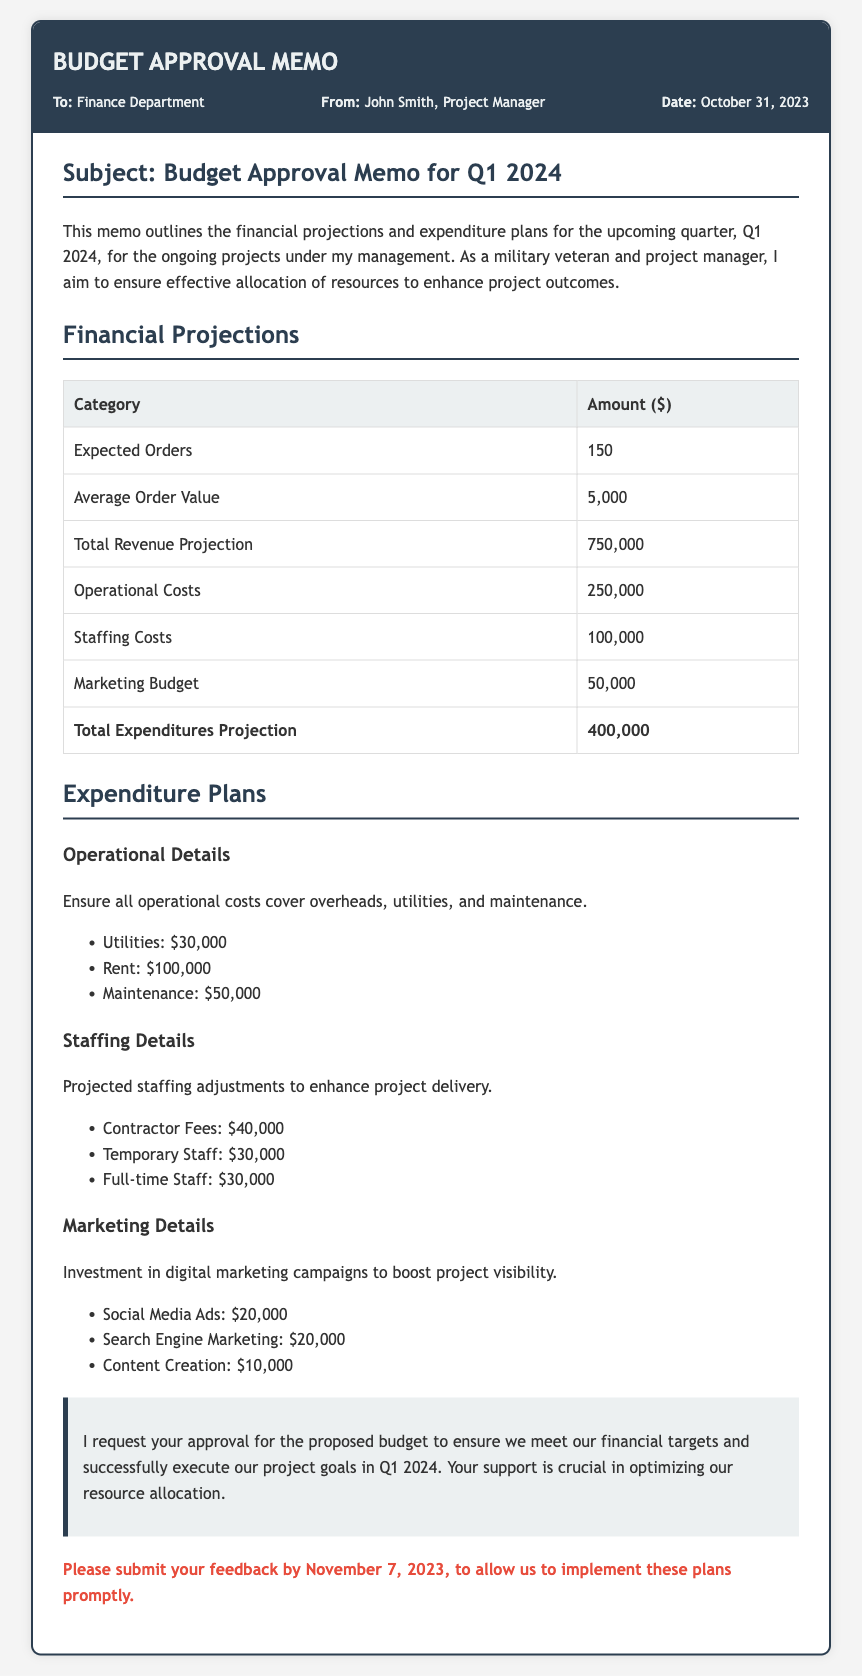what is the total revenue projection? The total revenue projection is directly listed in the financial projections section of the document.
Answer: 750,000 what is the date of the memo? The date of the memo is mentioned in the header section.
Answer: October 31, 2023 who is the sender of the memo? The sender is indicated in the header information of the memo.
Answer: John Smith what is the marketing budget amount? The marketing budget is shown in the financial projections table of the document.
Answer: 50,000 how much is allocated for staffing costs? Staffing costs are specified in the financial projections section of the document.
Answer: 100,000 what are the total expenditures projection? The total expenditures projection is provided at the end of the expenditures projections table.
Answer: 400,000 which department should respond to the memo? The recipient department is mentioned in the header section of the document.
Answer: Finance Department what specific feedback date is mentioned in the memo? The feedback date is requested towards the end of the memo.
Answer: November 7, 2023 what type of details are included in the expenditure plans? The expenditure plans section breaks down the operational, staffing, and marketing details.
Answer: Operational, Staffing, Marketing 